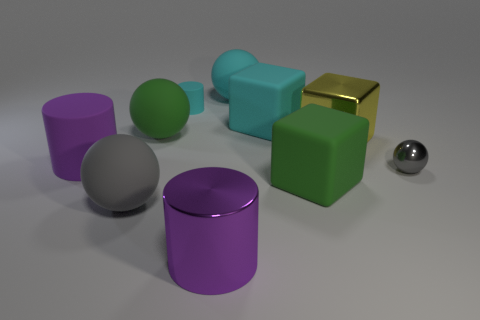Is the size of the rubber object that is behind the small cyan cylinder the same as the green matte object on the left side of the cyan sphere?
Keep it short and to the point. Yes. There is a sphere that is right of the rubber ball on the right side of the large purple metal cylinder; is there a cyan matte cylinder that is in front of it?
Provide a short and direct response. No. Are there fewer purple cylinders in front of the large matte cylinder than large metal cylinders behind the shiny cube?
Your answer should be very brief. No. There is a yellow thing that is the same material as the small ball; what is its shape?
Your answer should be very brief. Cube. How big is the rubber block on the right side of the block that is behind the green matte thing that is left of the large purple shiny object?
Make the answer very short. Large. Is the number of gray objects greater than the number of yellow blocks?
Offer a very short reply. Yes. There is a large cylinder that is behind the purple metallic cylinder; does it have the same color as the shiny thing in front of the tiny gray thing?
Provide a short and direct response. Yes. Is the large purple object that is on the left side of the cyan cylinder made of the same material as the gray sphere that is in front of the small metallic object?
Make the answer very short. Yes. What number of purple objects are the same size as the green ball?
Keep it short and to the point. 2. Are there fewer gray rubber spheres than big red cylinders?
Offer a terse response. No. 